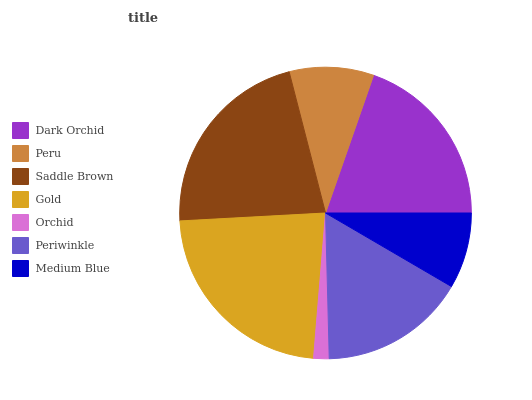Is Orchid the minimum?
Answer yes or no. Yes. Is Gold the maximum?
Answer yes or no. Yes. Is Peru the minimum?
Answer yes or no. No. Is Peru the maximum?
Answer yes or no. No. Is Dark Orchid greater than Peru?
Answer yes or no. Yes. Is Peru less than Dark Orchid?
Answer yes or no. Yes. Is Peru greater than Dark Orchid?
Answer yes or no. No. Is Dark Orchid less than Peru?
Answer yes or no. No. Is Periwinkle the high median?
Answer yes or no. Yes. Is Periwinkle the low median?
Answer yes or no. Yes. Is Peru the high median?
Answer yes or no. No. Is Gold the low median?
Answer yes or no. No. 